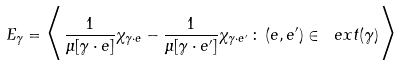<formula> <loc_0><loc_0><loc_500><loc_500>E _ { \gamma } = \Big < \frac { 1 } { \mu [ \gamma \cdot e ] } \chi _ { \gamma \cdot e } - \frac { 1 } { \mu [ \gamma \cdot e ^ { \prime } ] } \chi _ { \gamma \cdot e ^ { \prime } } \, \colon \, ( e , e ^ { \prime } ) \in \ e x t ( \gamma ) \Big ></formula> 